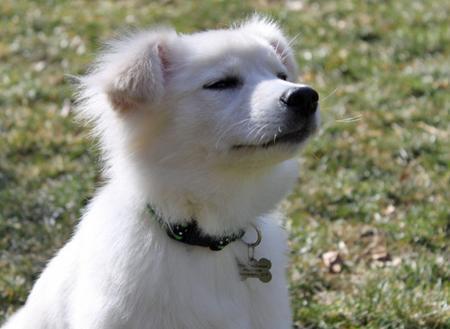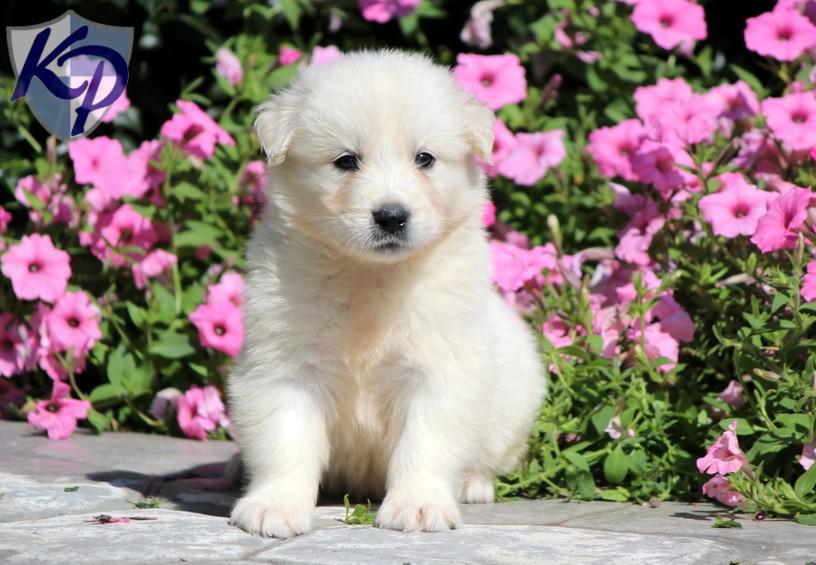The first image is the image on the left, the second image is the image on the right. Examine the images to the left and right. Is the description "There is a flowering plant behind one of the dogs." accurate? Answer yes or no. Yes. The first image is the image on the left, the second image is the image on the right. Evaluate the accuracy of this statement regarding the images: "there ia a puppy sitting on something that isn't grass". Is it true? Answer yes or no. Yes. The first image is the image on the left, the second image is the image on the right. For the images displayed, is the sentence "One white dog is shown with flowers in the background in one image." factually correct? Answer yes or no. Yes. The first image is the image on the left, the second image is the image on the right. Evaluate the accuracy of this statement regarding the images: "There are exactly three dogs.". Is it true? Answer yes or no. No. 